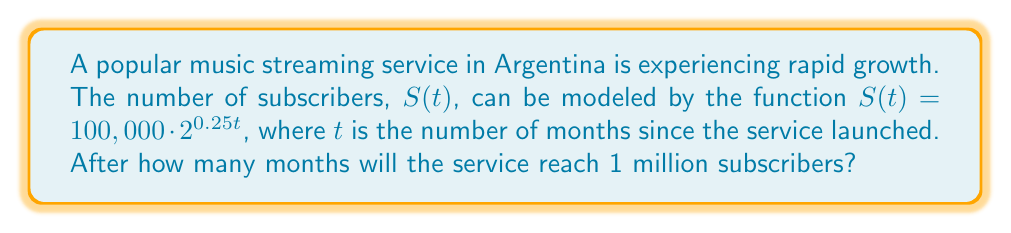Provide a solution to this math problem. To solve this problem, we need to use logarithms. Let's approach this step-by-step:

1) We want to find $t$ when $S(t) = 1,000,000$. So, we can set up the equation:

   $1,000,000 = 100,000 \cdot 2^{0.25t}$

2) Divide both sides by 100,000:

   $10 = 2^{0.25t}$

3) Now, we can apply the logarithm (base 2) to both sides:

   $\log_2(10) = \log_2(2^{0.25t})$

4) Using the logarithm property $\log_a(a^x) = x$, we get:

   $\log_2(10) = 0.25t$

5) Now, solve for $t$:

   $t = \frac{\log_2(10)}{0.25}$

6) We can change the base of the logarithm to a more common base (e.g., base 10) using the change of base formula:

   $t = \frac{\log_{10}(10)}{\log_{10}(2) \cdot 0.25} = \frac{1}{0.25 \cdot \log_{10}(2)}$

7) Calculate the result:

   $t \approx 13.29$

8) Since we're dealing with months, we need to round up to the nearest whole number.
Answer: The service will reach 1 million subscribers after 14 months. 